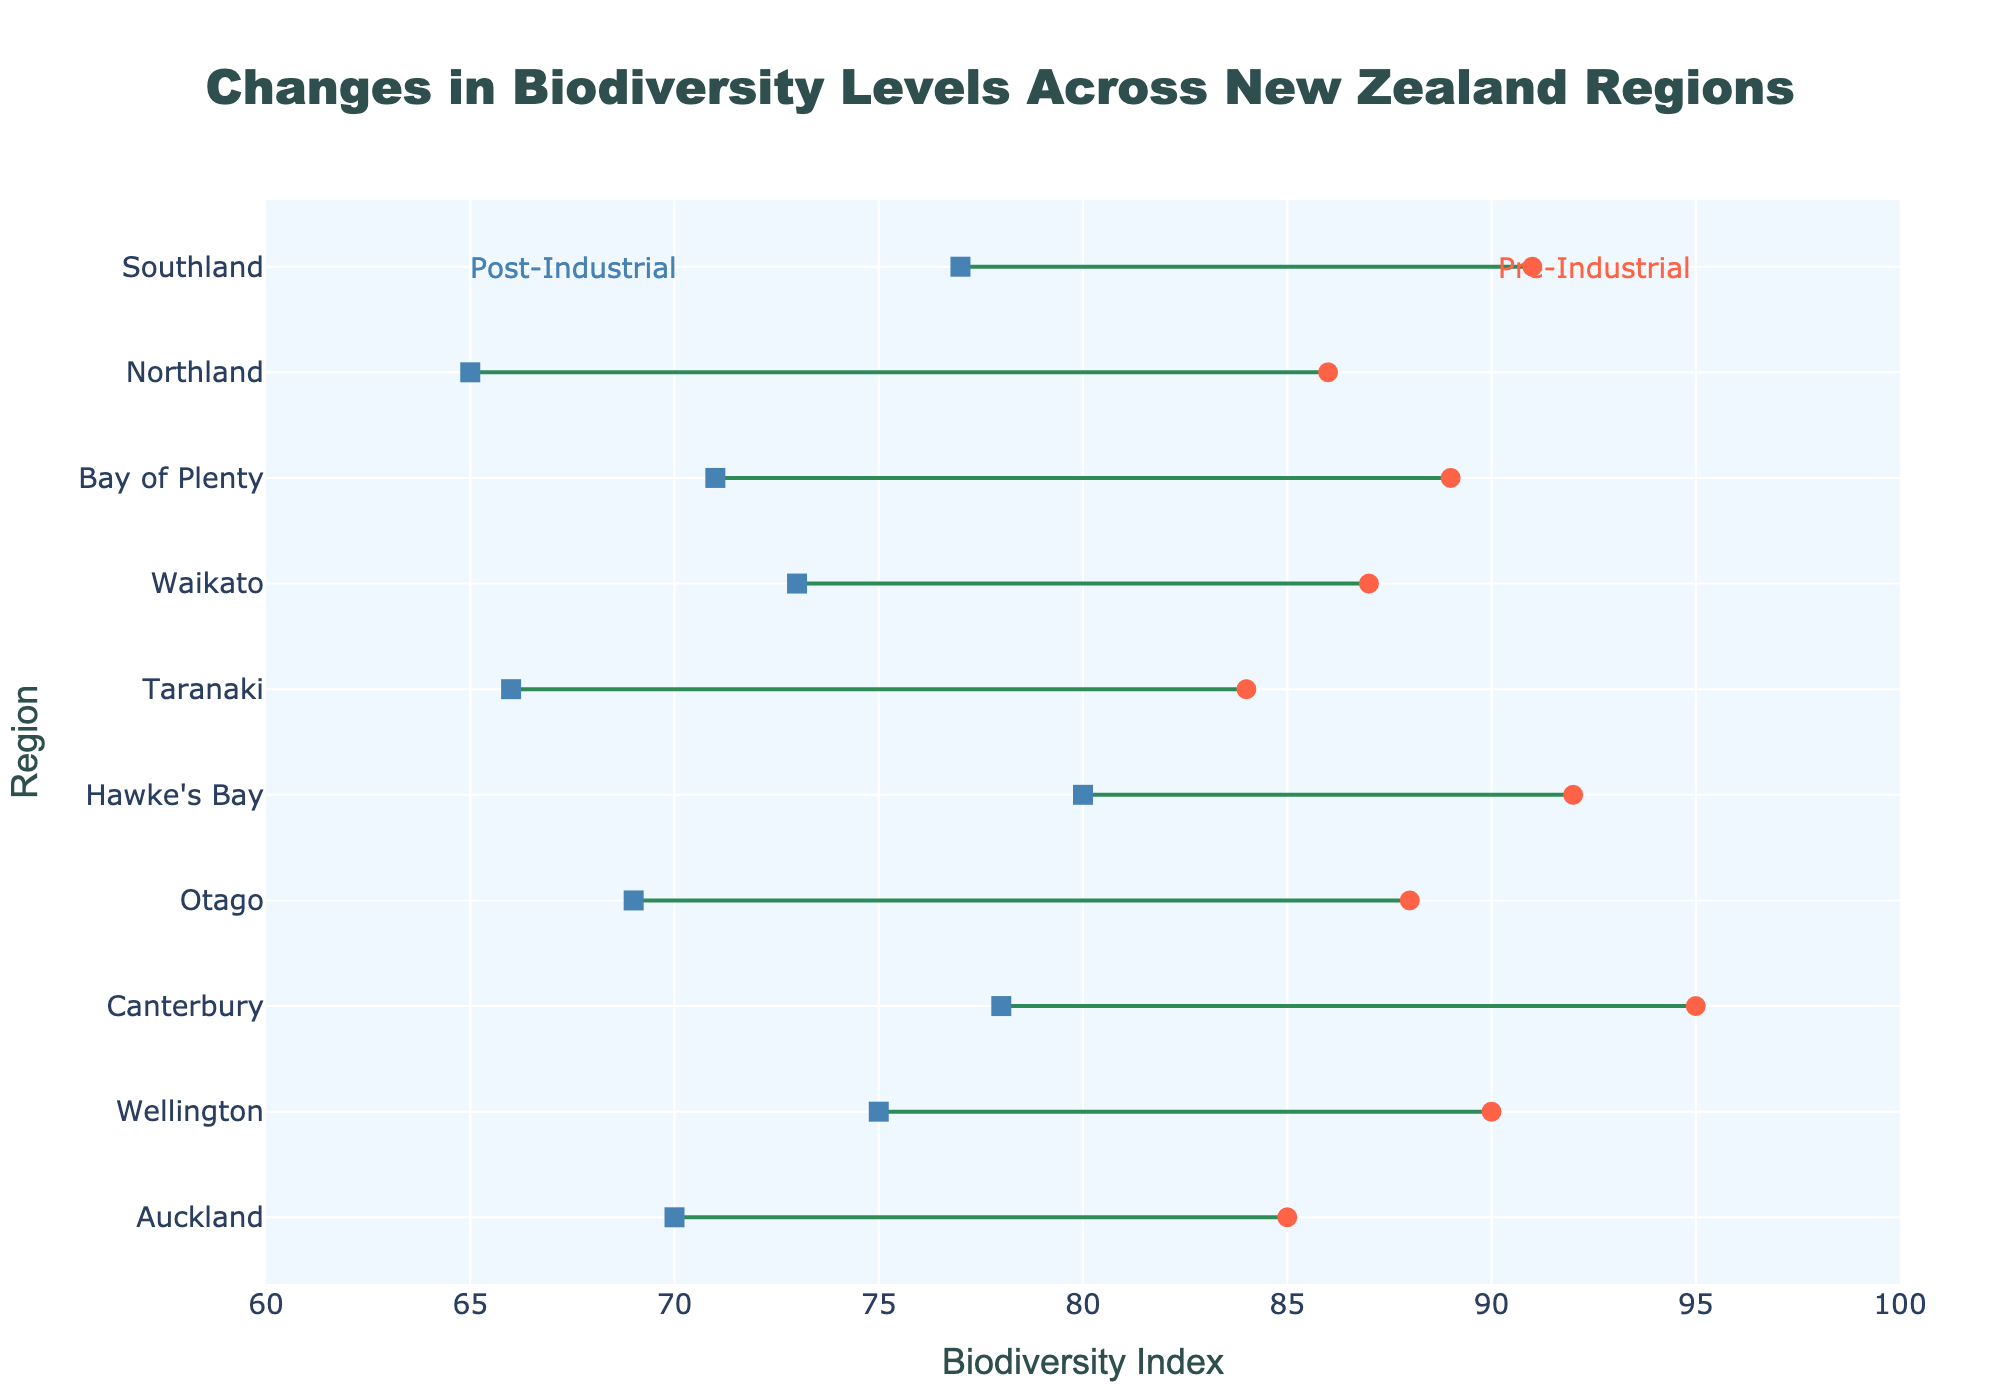What's the title of the plot? The title is prominently displayed at the top of the plot and is intended to describe the overall theme of the data being visualized.
Answer: Changes in Biodiversity Levels Across New Zealand Regions What does the x-axis represent? The x-axis title indicates the variable being measured along this axis, which is related to biodiversity levels.
Answer: Biodiversity Index Which region has the highest biodiversity index post-industrial activities, and what is the value? To find this, look for the region with the highest marker on the post-industrial side of the plot.
Answer: Hawke's Bay, 80 What is the average pre-industrial biodiversity index for all regions? Sum all pre-industrial biodiversity indices (85+90+95+88+92+84+87+89+86+91) and divide by the number of regions, which is 10.
Answer: 88.7 Which region experienced the largest decrease in biodiversity index, and what is the value of the decrease? Calculate the difference between pre-industrial and post-industrial indices for each region, and identify the maximum difference.
Answer: Northland, 21 Are there any regions where biodiversity index remains above 75 post-industrial activities? Look for regions whose post-industrial index is greater than 75.
Answer: Yes, Wellington, Canterbury, Hawke's Bay, and Southland How much did the biodiversity index decrease on average across all regions? Calculate the decrease for each region, sum these decreases, and then divide by the number of regions. Differences are (15, 15, 17, 19, 12, 18, 14, 18, 21, 14). Sum = 163, average = 163/10.
Answer: 16.3 Which region showed the smallest change in biodiversity index, and what was the value of the change? Identify the region with the smallest difference between pre- and post-industrial biodiversity indices.
Answer: Hawke's Bay, 12 How many regions had a post-industrial biodiversity index below 70? Count the number of regions whose post-industrial index is less than 70.
Answer: 4 regions (Auckland, Otago, Taranaki, Northland) What's the difference in biodiversity index between Auckland and Wellington pre-industrial activities? Subtract Auckland's pre-industrial index from Wellington's pre-industrial index.
Answer: 5 